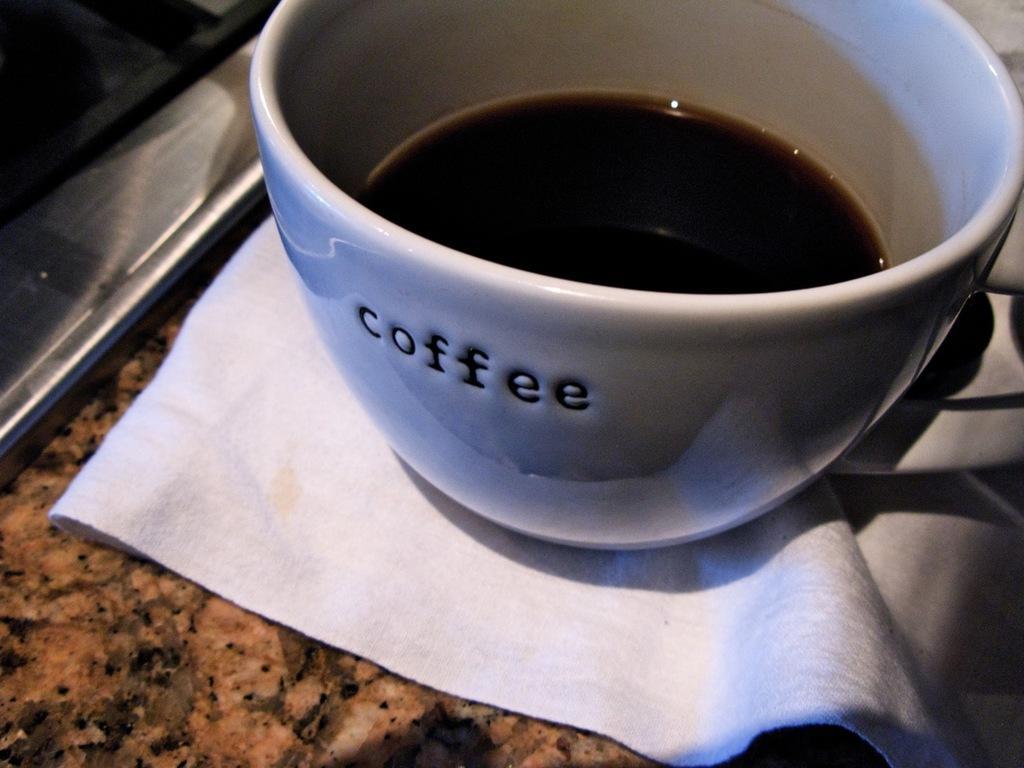Could you give a brief overview of what you see in this image? This picture shows a coffee cup and a napkin on the countertop. 